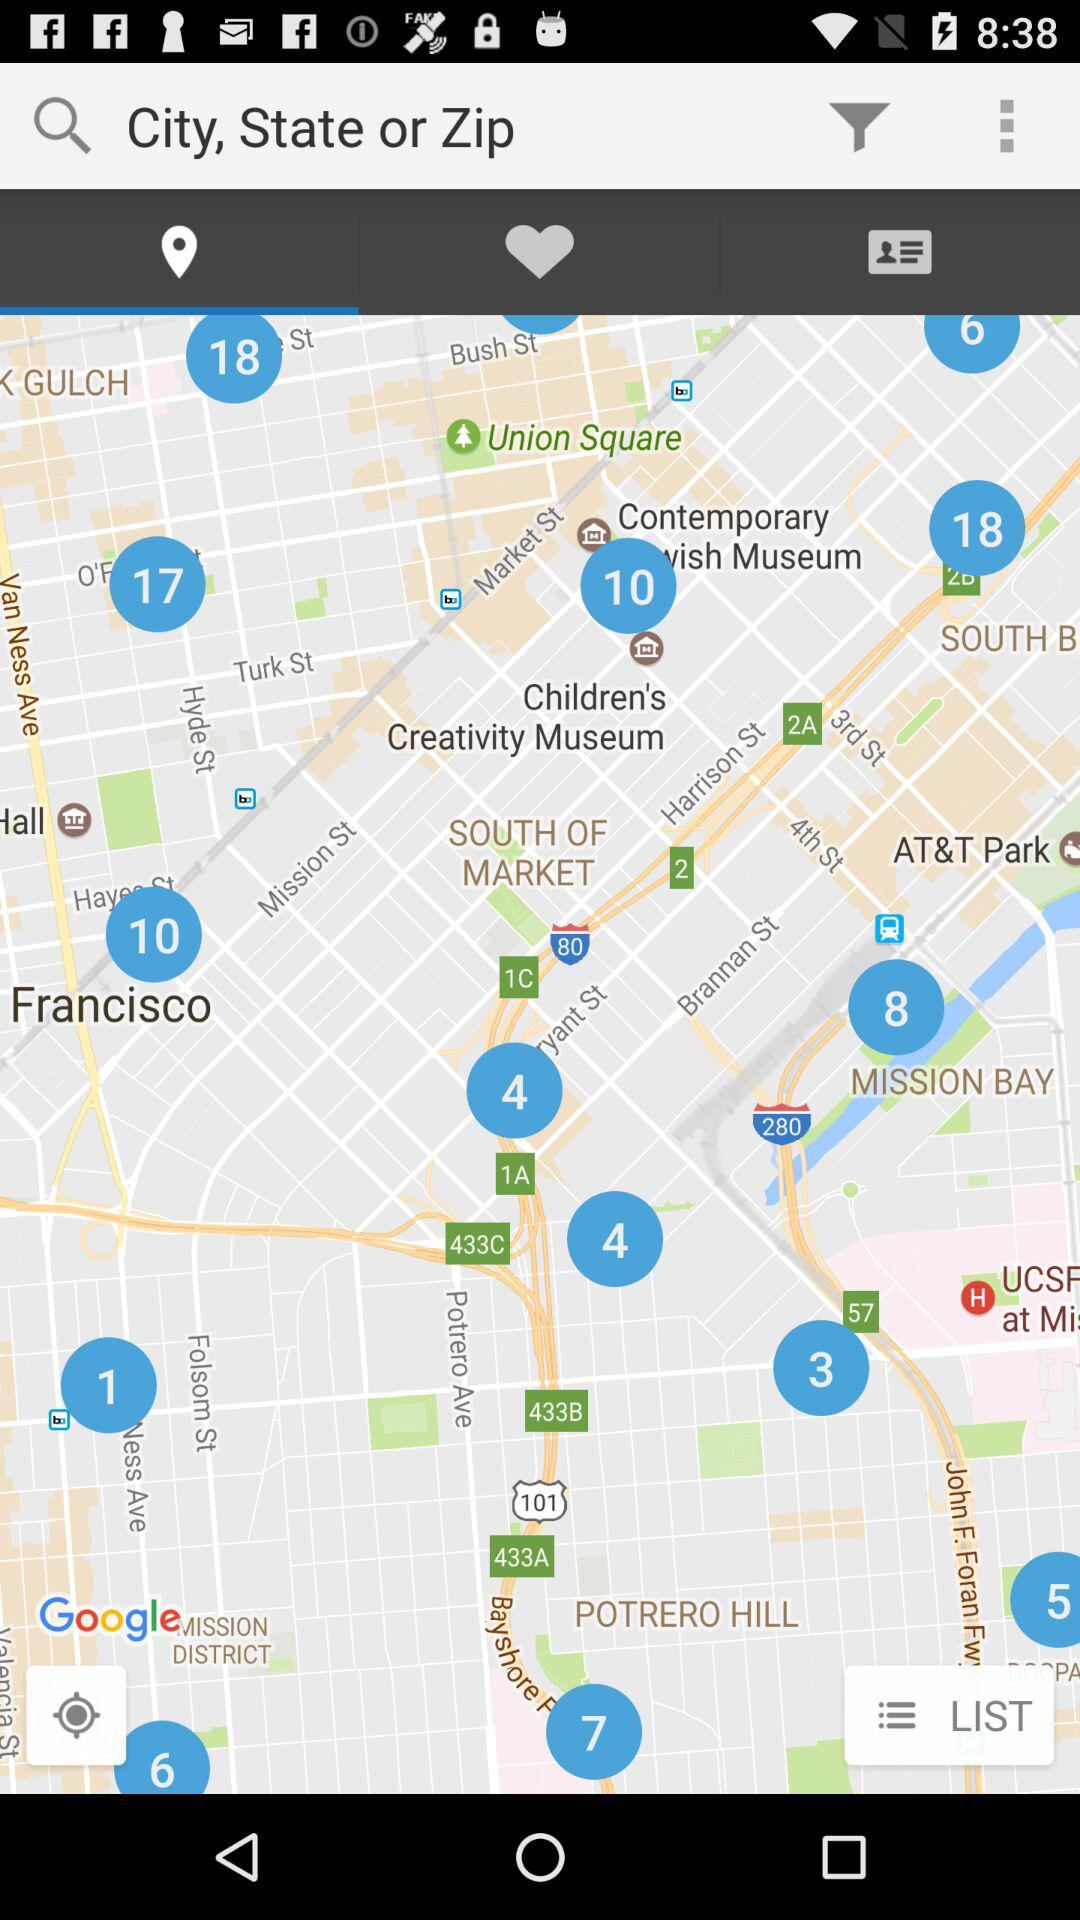Which tab has been selected? The selected tab is "Location". 